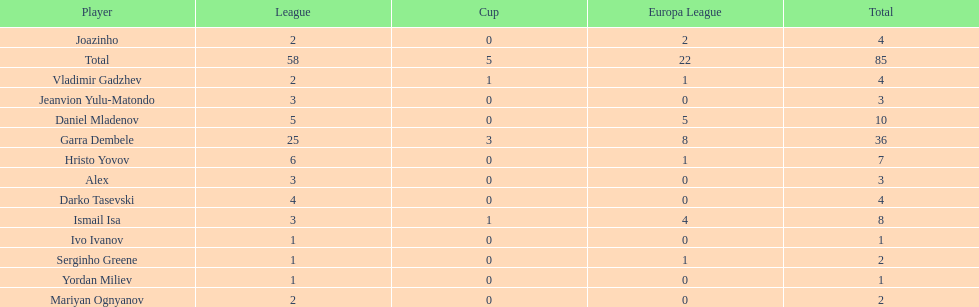Which players only scored one goal? Serginho Greene, Yordan Miliev, Ivo Ivanov. 